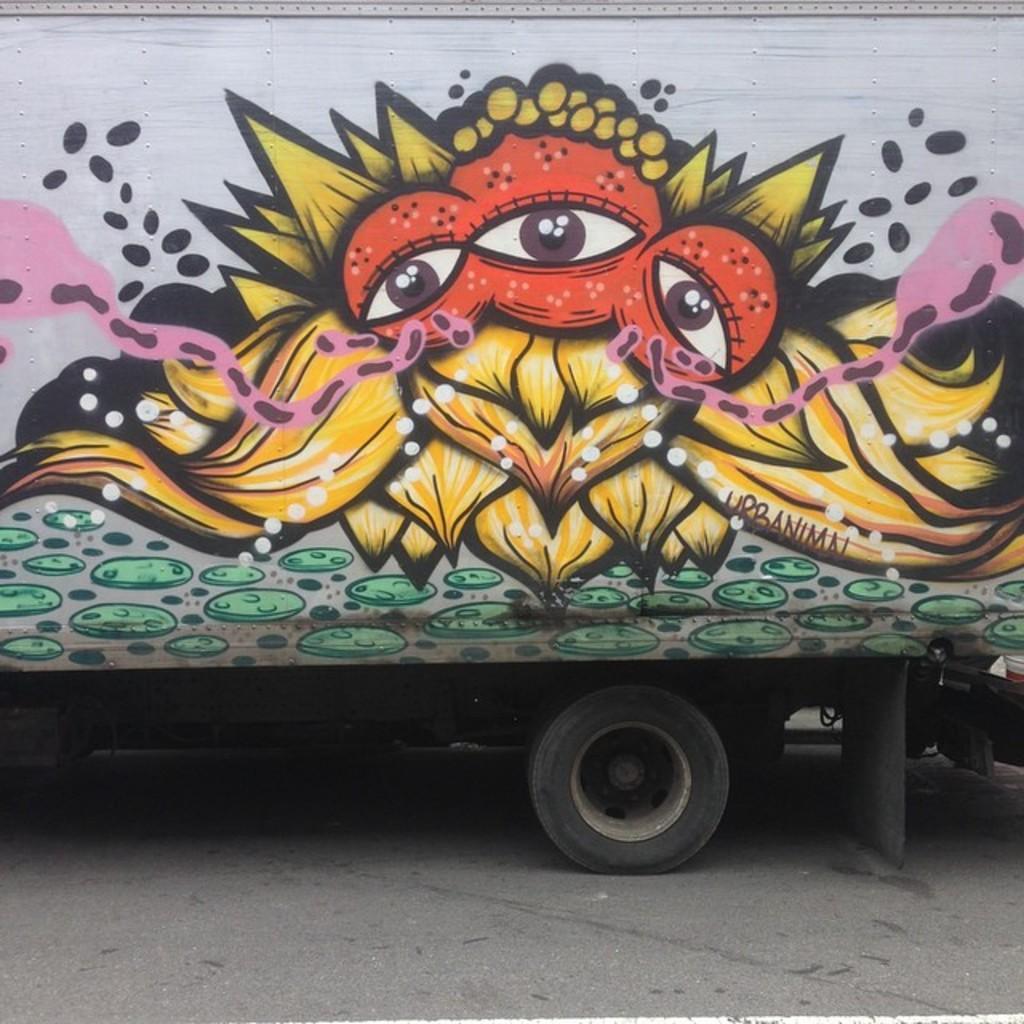Describe this image in one or two sentences. In this picture there is a bus in the center of the image, on which there is painting. 